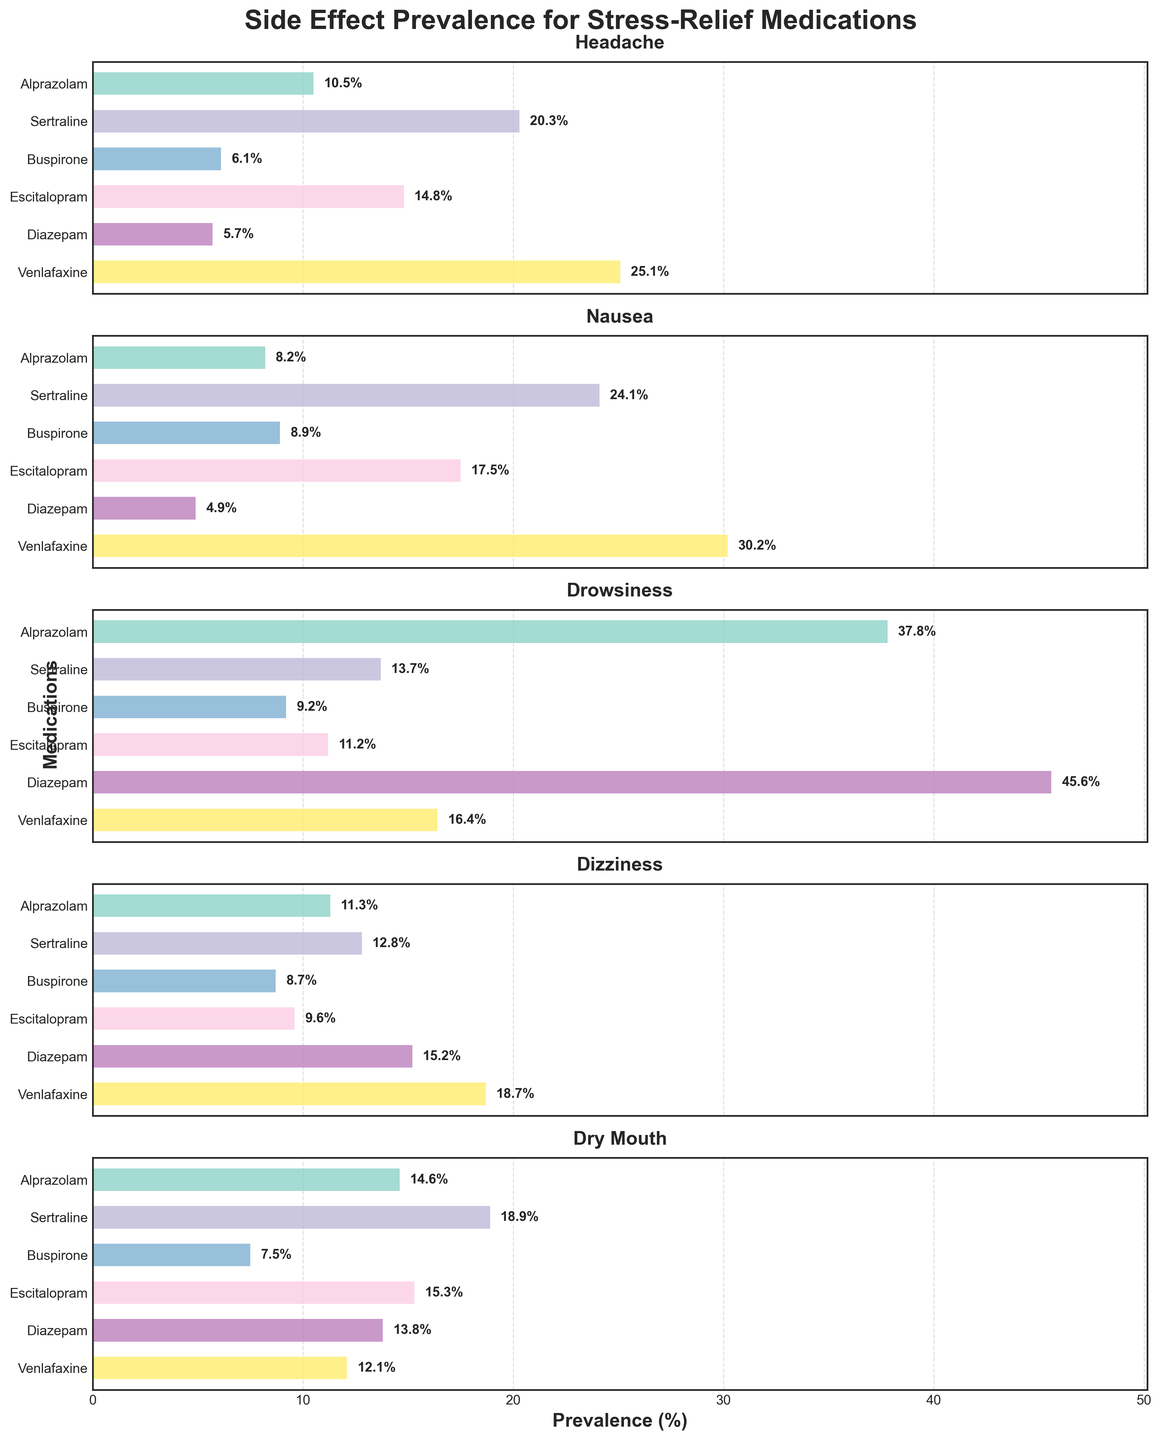What is the prevalence (%) of Drowsiness for Diazepam? Locate the subplot titled "Drowsiness". Then, find the bar corresponding to "Diazepam" and read the value next to the bar.
Answer: 45.6% Which side effect has the highest prevalence for Venlafaxine, and what is that value? Locate the bars corresponding to "Venlafaxine" across all subplots. Identify the subplot with the largest bar and read the value next to it.
Answer: Nausea, 30.2% What is the average prevalence (%) of Headache across all medications? Locate the subplot titled "Headache". Sum up the values for all drugs (10.5, 20.3, 6.1, 14.8, 5.7, 25.1) and divide by the total number of drugs (6). (10.5 + 20.3 + 6.1 + 14.8 + 5.7 + 25.1) / 6 = 13.75
Answer: 13.75% Which medication has the lowest prevalence (%) of Dizziness and what is the value? Locate the subplot titled "Dizziness". Compare the heights of the bars and find the smallest one. Read the value next to this bar.
Answer: Buspirone, 8.7% Compare the prevalence (%) of Nausea between Alprazolam and Sertraline. Which is higher and by how much? Locate the subplot titled "Nausea". Find the values for "Alprazolam" and "Sertraline". Subtract the smaller value from the larger one. 24.1% (Sertraline) - 8.2% (Alprazolam) = 15.9%
Answer: Sertraline is higher by 15.9% Which medication has the most similar prevalence (%) of Dry Mouth to Alprazolam, and what is the value? Locate the subplot titled "Dry Mouth". Compare the bars and find the one closest in height to Alprazolam's bar (14.6%). Sertraline has a prevalence of 18.9%, nearest to Alprazolam's 14.6%.
Answer: Sertraline, 18.9% For Escitalopram, which side effect has the lowest prevalence (%) and what is the value? Locate the bars corresponding to "Escitalopram" across all subplots. Identify the smallest bar and read the value next to it.
Answer: Dizziness, 9.6% How many medications have a higher prevalence (%) of Dry Mouth than Drowsiness? Locate the subplots titled "Dry Mouth" and "Drowsiness". Compare the heights of bars for each drug in these subplots. Count the number of drugs where the Dry Mouth bar is higher than the Drowsiness bar. Alprazolam, Escitalopram.
Answer: 2 medications What is the total prevalence (%) of Headache for Alprazolam, Sertraline, and Buspirone combined? Locate the subplot titled "Headache". Sum the values for Alprazolam (10.5), Sertraline (20.3), and Buspirone (6.1). (10.5 + 20.3 + 6.1) = 36.9.
Answer: 36.9% Which side effect has a higher maximum prevalence value: Drowsiness or Dizziness, and what are these values? Locate the subplots titled "Drowsiness" and "Dizziness". Identify the highest bar in each subplot and read the values next to them. Drowsiness has a highest value of 45.6%, Dizziness has a highest value of 18.7%.
Answer: Drowsiness, 45.6% 